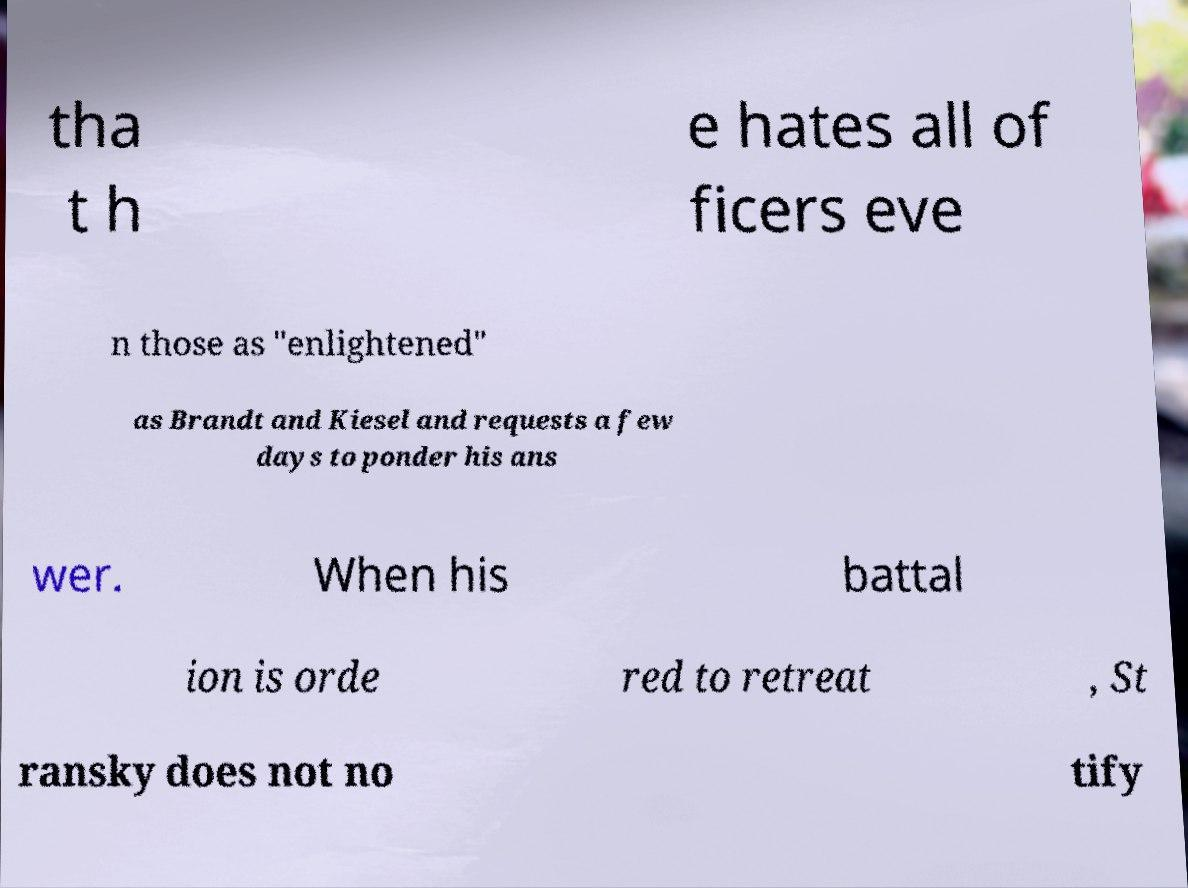Please read and relay the text visible in this image. What does it say? tha t h e hates all of ficers eve n those as "enlightened" as Brandt and Kiesel and requests a few days to ponder his ans wer. When his battal ion is orde red to retreat , St ransky does not no tify 